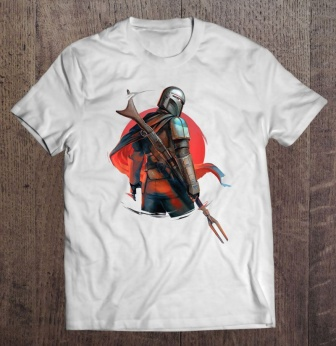What do you think the significance of the red background might be in the context of this t-shirt design? The vivid red circle behind the knight likely symbolizes strength and courage, often associated with the color red. In artistic representations, red can denote energy and passion, perhaps implying that the knight stands ready to defend or fight with fervor and valor. This color choice enhances the dramatic impact of the design and draws attention to the knight as the central figure. 